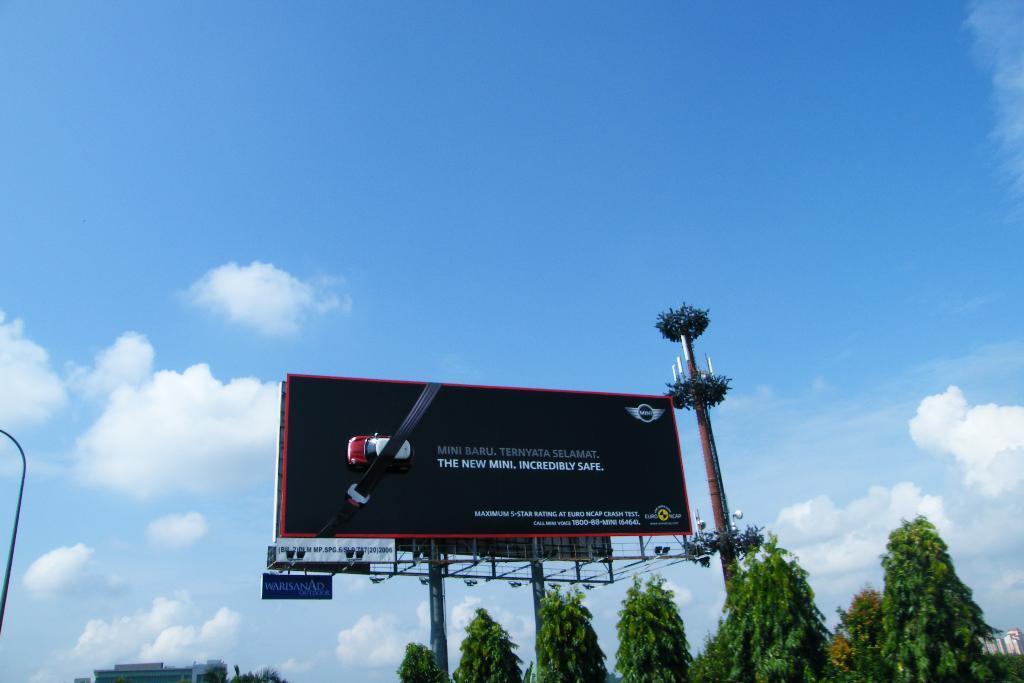Can you describe this image briefly? In this picture we can see some text, an image of a car and a few things on the boards. We can see planets on a pole. There are a few trees and other objects. We can see the cloudy sky. 